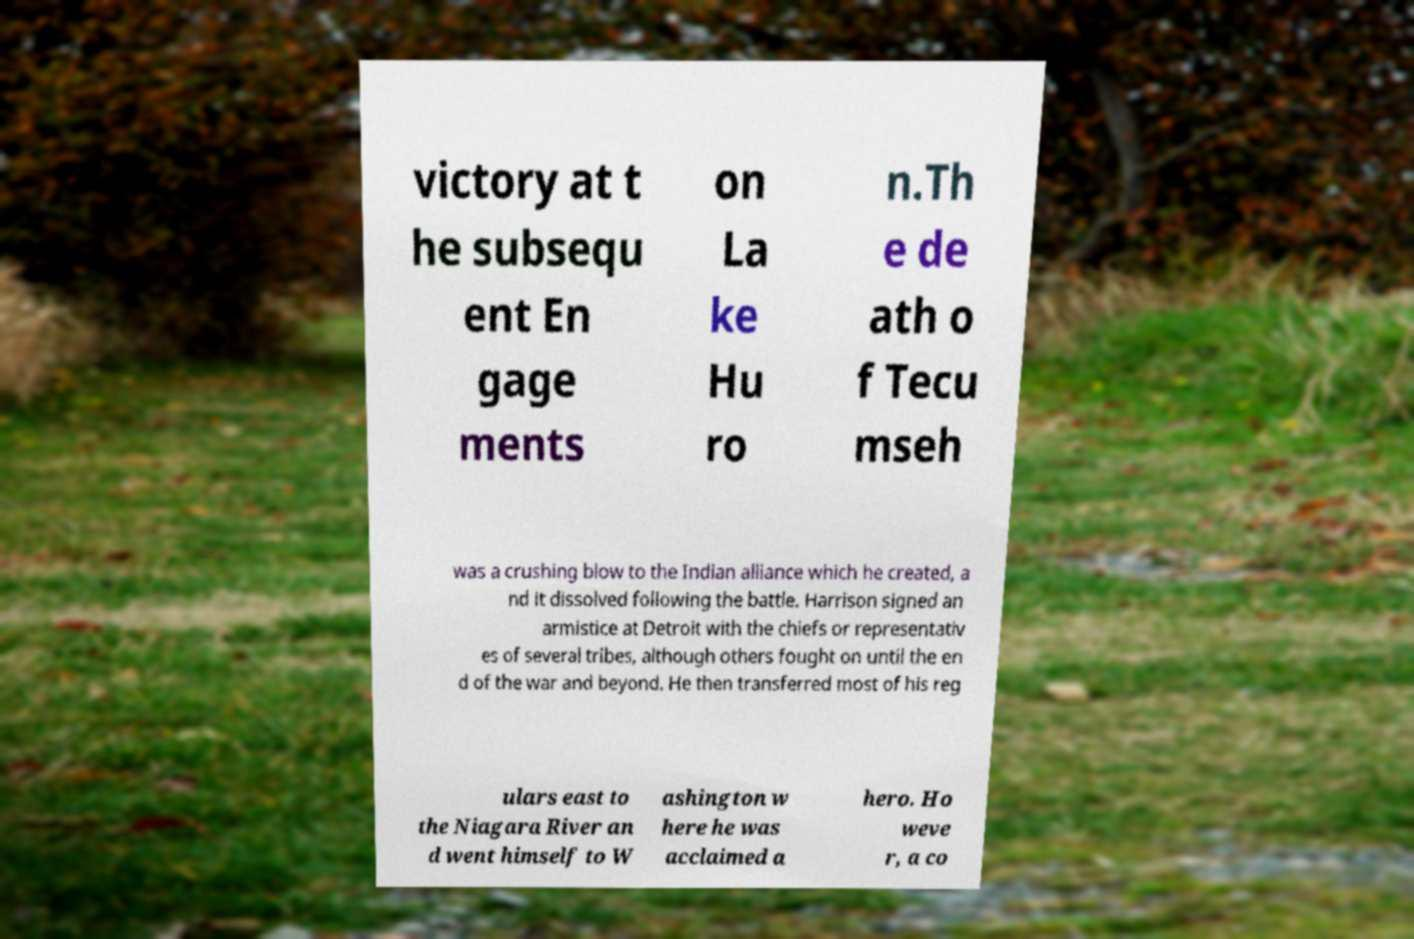There's text embedded in this image that I need extracted. Can you transcribe it verbatim? victory at t he subsequ ent En gage ments on La ke Hu ro n.Th e de ath o f Tecu mseh was a crushing blow to the Indian alliance which he created, a nd it dissolved following the battle. Harrison signed an armistice at Detroit with the chiefs or representativ es of several tribes, although others fought on until the en d of the war and beyond. He then transferred most of his reg ulars east to the Niagara River an d went himself to W ashington w here he was acclaimed a hero. Ho weve r, a co 